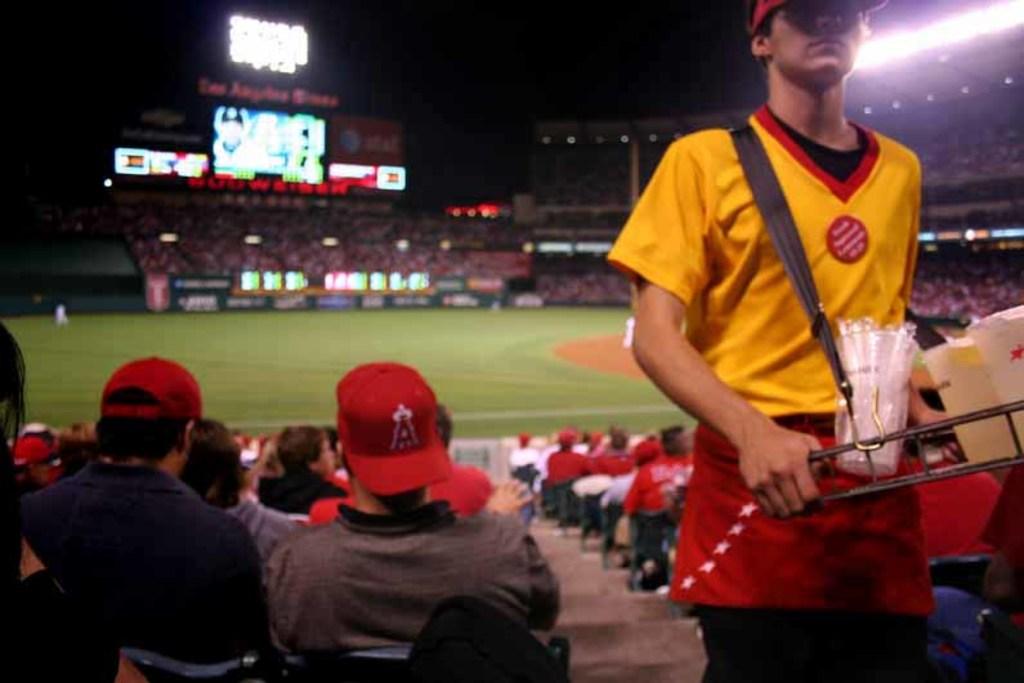What letter is on the baseball cap?
Provide a short and direct response. A. 